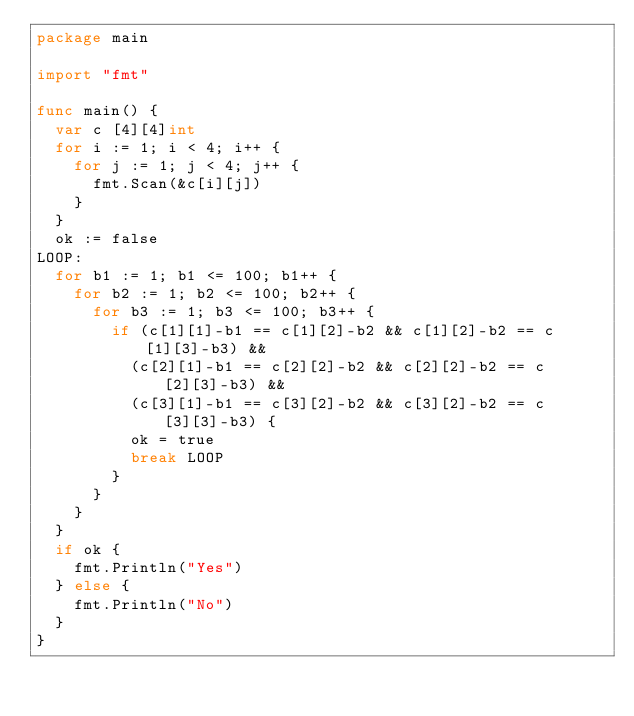Convert code to text. <code><loc_0><loc_0><loc_500><loc_500><_Go_>package main

import "fmt"

func main() {
	var c [4][4]int
	for i := 1; i < 4; i++ {
		for j := 1; j < 4; j++ {
			fmt.Scan(&c[i][j])
		}
	}
	ok := false
LOOP:
	for b1 := 1; b1 <= 100; b1++ {
		for b2 := 1; b2 <= 100; b2++ {
			for b3 := 1; b3 <= 100; b3++ {
				if (c[1][1]-b1 == c[1][2]-b2 && c[1][2]-b2 == c[1][3]-b3) &&
					(c[2][1]-b1 == c[2][2]-b2 && c[2][2]-b2 == c[2][3]-b3) &&
					(c[3][1]-b1 == c[3][2]-b2 && c[3][2]-b2 == c[3][3]-b3) {
					ok = true
					break LOOP
				}
			}
		}
	}
	if ok {
		fmt.Println("Yes")
	} else {
		fmt.Println("No")
	}
}
</code> 